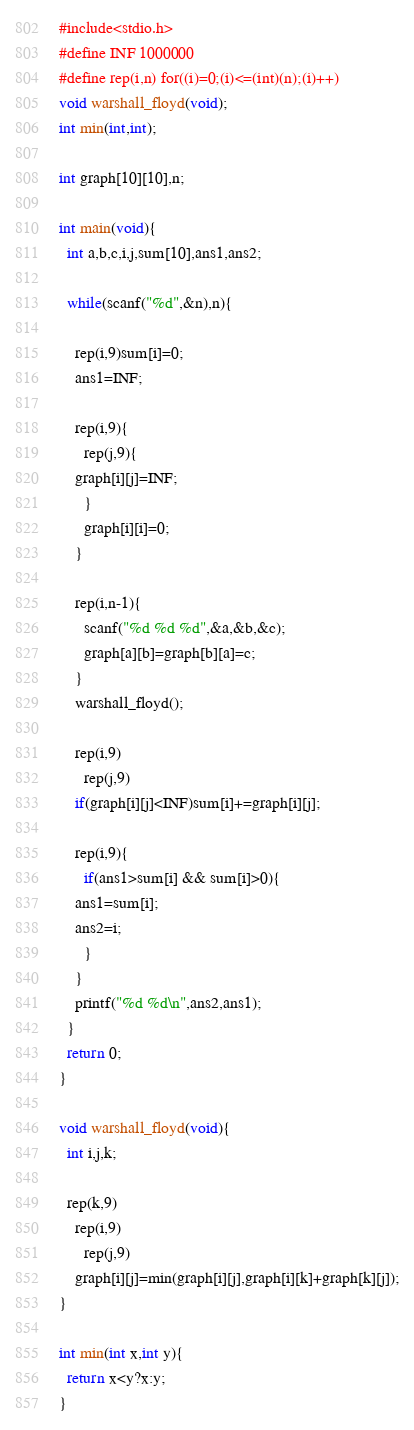<code> <loc_0><loc_0><loc_500><loc_500><_C_>#include<stdio.h>
#define INF 1000000
#define rep(i,n) for((i)=0;(i)<=(int)(n);(i)++)
void warshall_floyd(void);
int min(int,int);

int graph[10][10],n;

int main(void){
  int a,b,c,i,j,sum[10],ans1,ans2;

  while(scanf("%d",&n),n){

    rep(i,9)sum[i]=0;
    ans1=INF;

    rep(i,9){
      rep(j,9){
	graph[i][j]=INF;
      }
      graph[i][i]=0;
    }
    
    rep(i,n-1){
      scanf("%d %d %d",&a,&b,&c);
      graph[a][b]=graph[b][a]=c;
    }
    warshall_floyd();

    rep(i,9)
      rep(j,9)
	if(graph[i][j]<INF)sum[i]+=graph[i][j];

    rep(i,9){
      if(ans1>sum[i] && sum[i]>0){
	ans1=sum[i];
	ans2=i;
      }
    }
    printf("%d %d\n",ans2,ans1);
  }
  return 0;
}

void warshall_floyd(void){
  int i,j,k;

  rep(k,9)
    rep(i,9)
      rep(j,9)
	graph[i][j]=min(graph[i][j],graph[i][k]+graph[k][j]);
}

int min(int x,int y){
  return x<y?x:y;
}</code> 